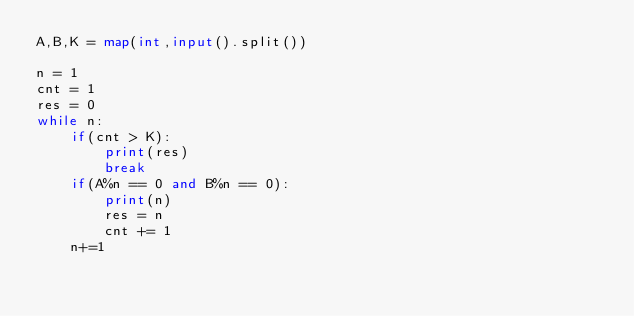<code> <loc_0><loc_0><loc_500><loc_500><_Python_>A,B,K = map(int,input().split())

n = 1
cnt = 1
res = 0
while n:
    if(cnt > K):
        print(res)
        break
    if(A%n == 0 and B%n == 0):
        print(n)
        res = n
        cnt += 1
    n+=1</code> 